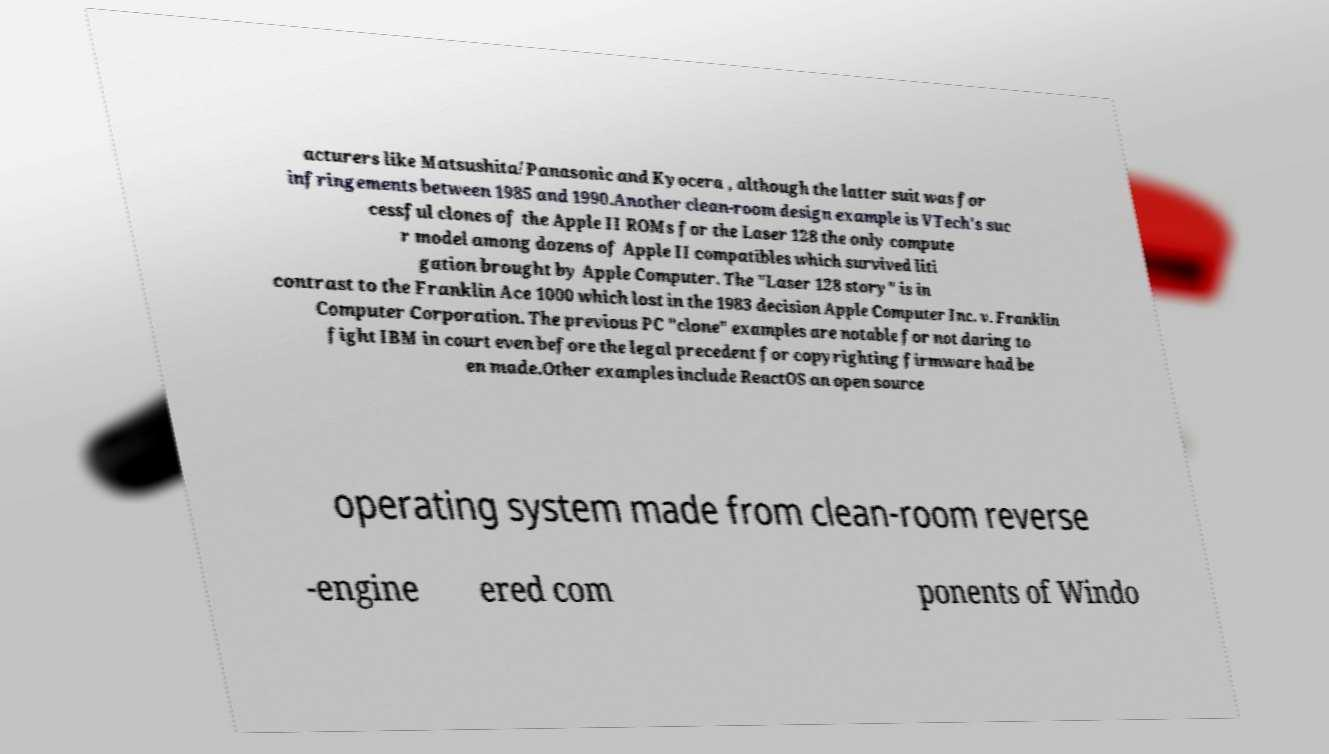Please identify and transcribe the text found in this image. acturers like Matsushita/Panasonic and Kyocera , although the latter suit was for infringements between 1985 and 1990.Another clean-room design example is VTech's suc cessful clones of the Apple II ROMs for the Laser 128 the only compute r model among dozens of Apple II compatibles which survived liti gation brought by Apple Computer. The "Laser 128 story" is in contrast to the Franklin Ace 1000 which lost in the 1983 decision Apple Computer Inc. v. Franklin Computer Corporation. The previous PC "clone" examples are notable for not daring to fight IBM in court even before the legal precedent for copyrighting firmware had be en made.Other examples include ReactOS an open source operating system made from clean-room reverse -engine ered com ponents of Windo 